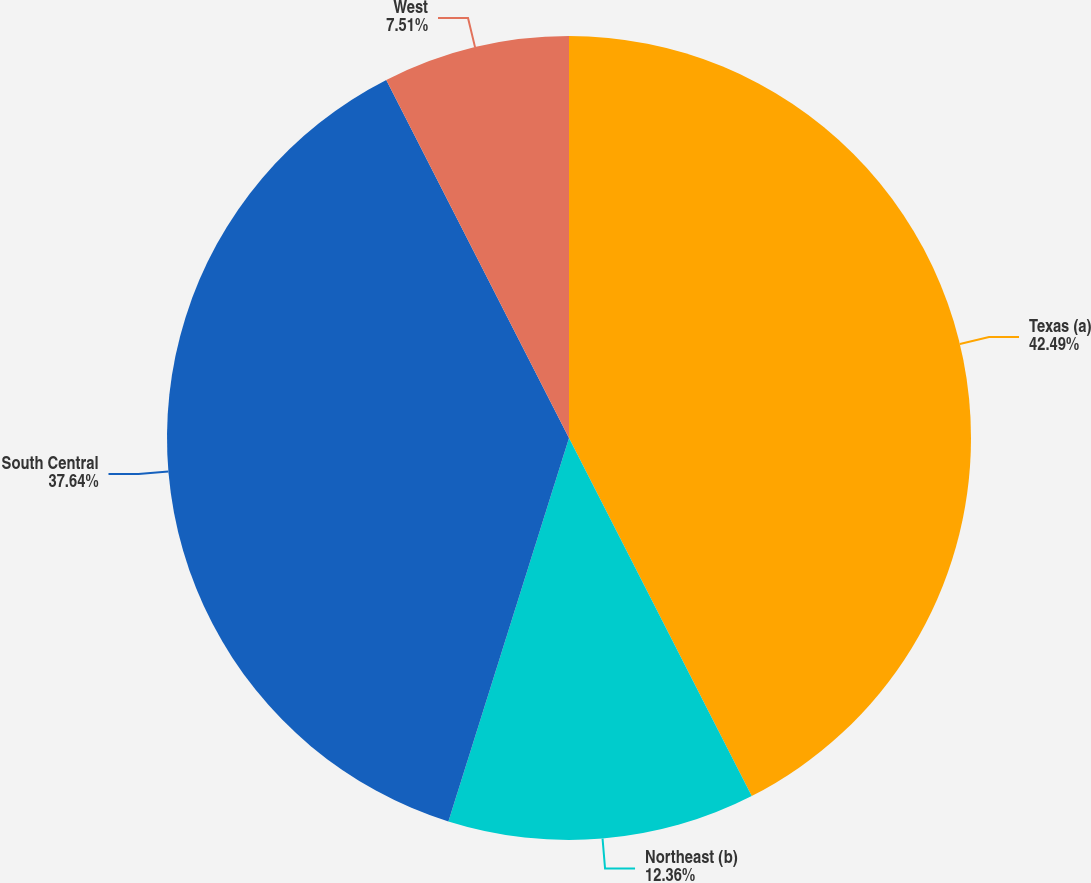<chart> <loc_0><loc_0><loc_500><loc_500><pie_chart><fcel>Texas (a)<fcel>Northeast (b)<fcel>South Central<fcel>West<nl><fcel>42.49%<fcel>12.36%<fcel>37.64%<fcel>7.51%<nl></chart> 